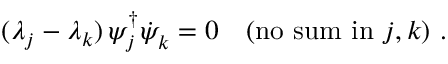<formula> <loc_0><loc_0><loc_500><loc_500>( \lambda _ { j } - \lambda _ { k } ) \, \psi _ { j } ^ { \dagger } { \dot { \psi } } _ { k } = 0 ( n o s u m i n j , k ) .</formula> 